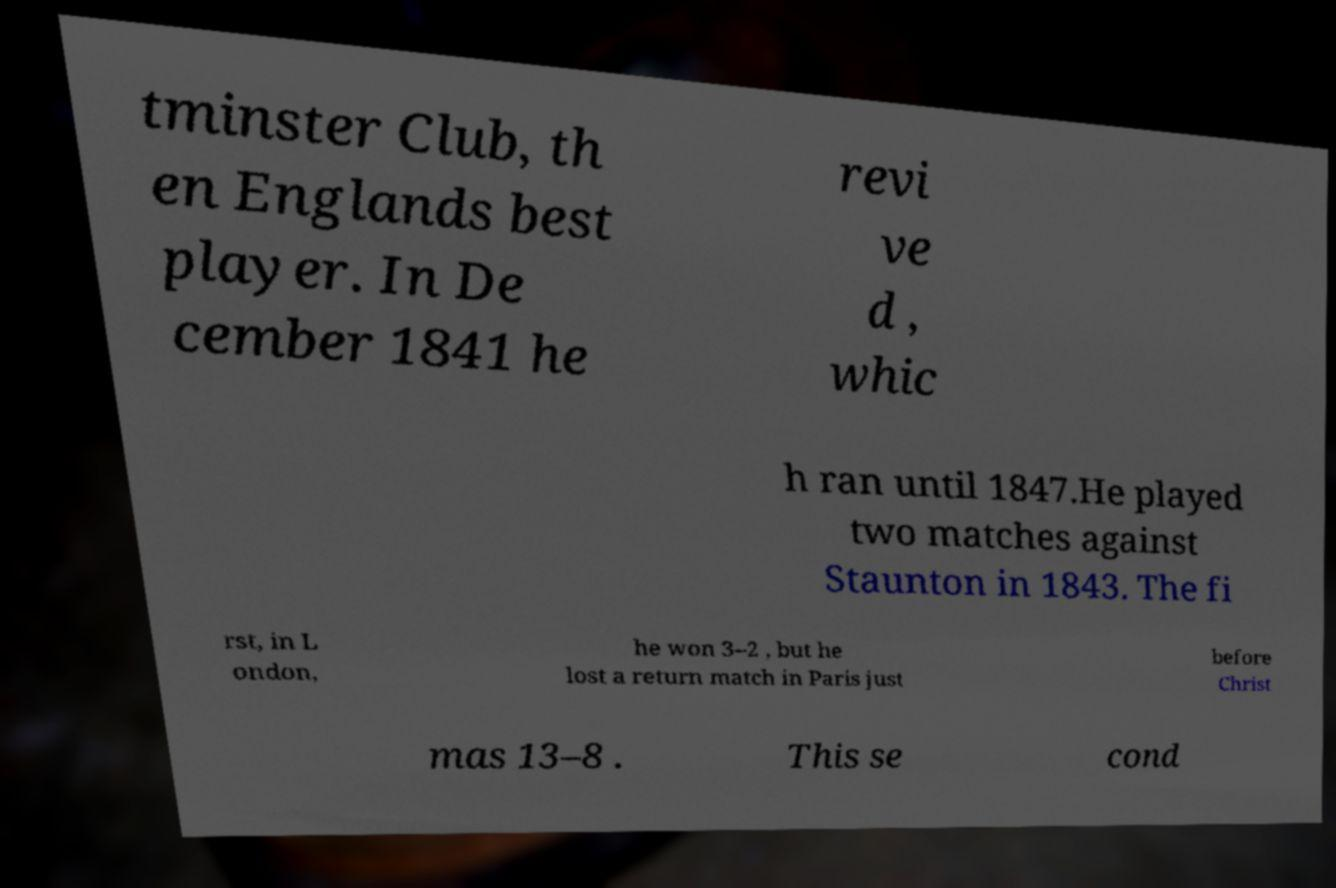For documentation purposes, I need the text within this image transcribed. Could you provide that? tminster Club, th en Englands best player. In De cember 1841 he revi ve d , whic h ran until 1847.He played two matches against Staunton in 1843. The fi rst, in L ondon, he won 3–2 , but he lost a return match in Paris just before Christ mas 13–8 . This se cond 